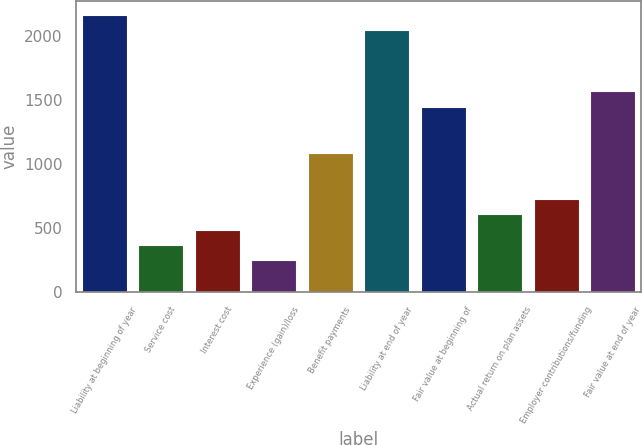<chart> <loc_0><loc_0><loc_500><loc_500><bar_chart><fcel>Liability at beginning of year<fcel>Service cost<fcel>Interest cost<fcel>Experience (gain)/loss<fcel>Benefit payments<fcel>Liability at end of year<fcel>Fair value at beginning of<fcel>Actual return on plan assets<fcel>Employer contributions/funding<fcel>Fair value at end of year<nl><fcel>2167.2<fcel>368.7<fcel>488.6<fcel>248.8<fcel>1088.1<fcel>2047.3<fcel>1447.8<fcel>608.5<fcel>728.4<fcel>1567.7<nl></chart> 